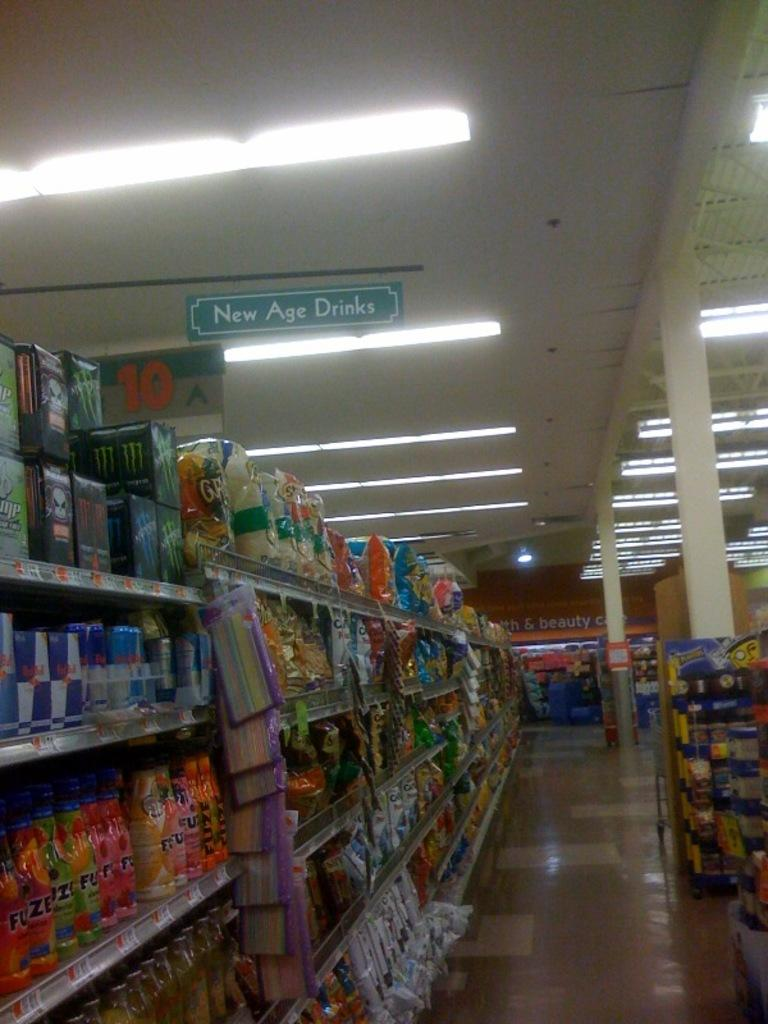<image>
Summarize the visual content of the image. A store aisle with a sign reading "New Age Drinks". 